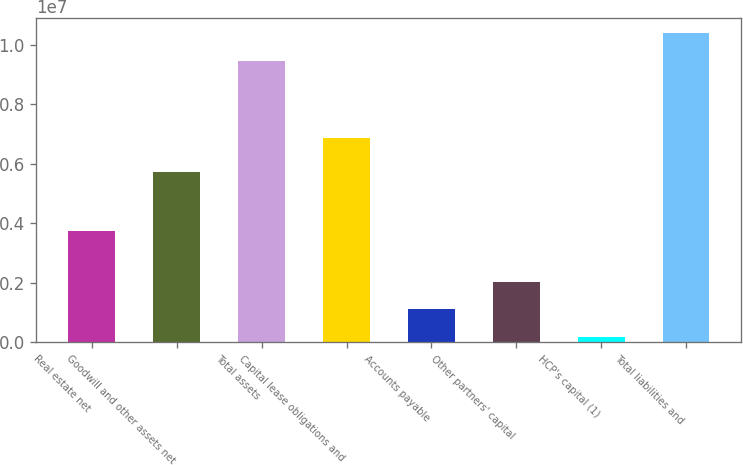<chart> <loc_0><loc_0><loc_500><loc_500><bar_chart><fcel>Real estate net<fcel>Goodwill and other assets net<fcel>Total assets<fcel>Capital lease obligations and<fcel>Accounts payable<fcel>Other partners' capital<fcel>HCP's capital (1)<fcel>Total liabilities and<nl><fcel>3.73174e+06<fcel>5.73432e+06<fcel>9.46606e+06<fcel>6.87593e+06<fcel>1.11144e+06<fcel>2.03973e+06<fcel>183146<fcel>1.03943e+07<nl></chart> 